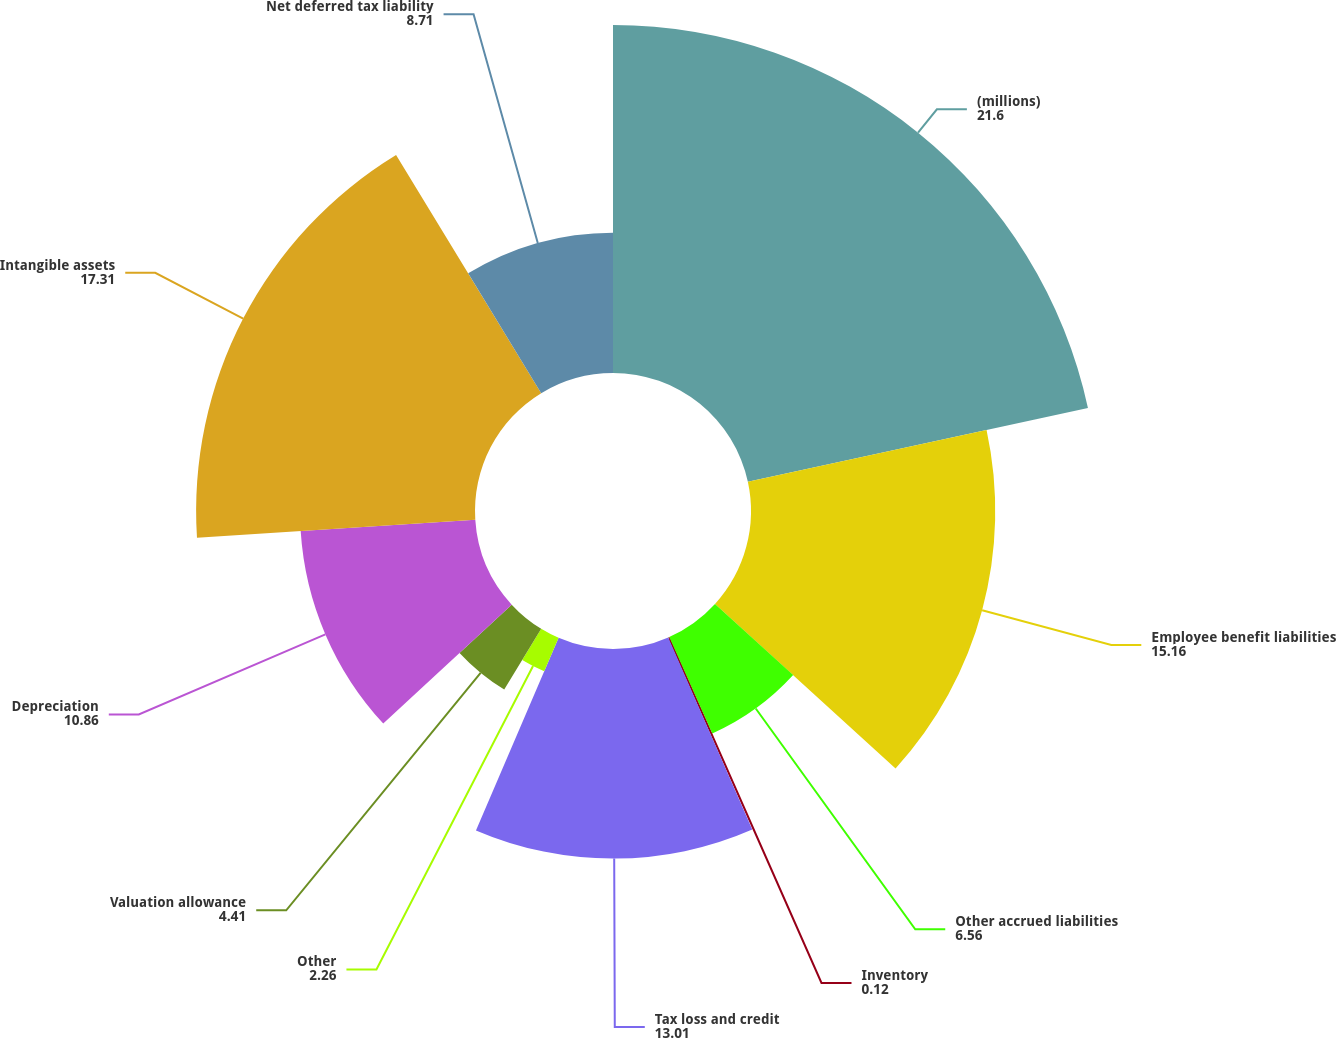<chart> <loc_0><loc_0><loc_500><loc_500><pie_chart><fcel>(millions)<fcel>Employee benefit liabilities<fcel>Other accrued liabilities<fcel>Inventory<fcel>Tax loss and credit<fcel>Other<fcel>Valuation allowance<fcel>Depreciation<fcel>Intangible assets<fcel>Net deferred tax liability<nl><fcel>21.6%<fcel>15.16%<fcel>6.56%<fcel>0.12%<fcel>13.01%<fcel>2.26%<fcel>4.41%<fcel>10.86%<fcel>17.31%<fcel>8.71%<nl></chart> 